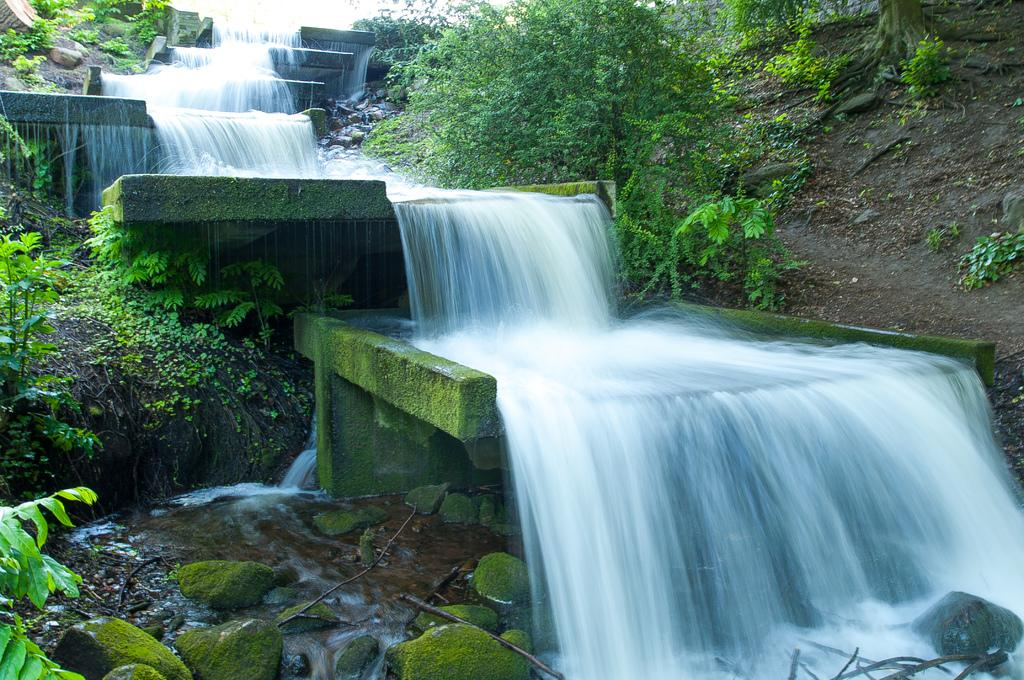What natural feature is the main subject of the image? There is a waterfall in the image. What type of vegetation can be seen in the image? There are plants in the image. What is located at the bottom of the image? There are stones at the bottom of the image. What is the name of the person standing in front of the waterfall in the image? There is no person standing in front of the waterfall in the image. 